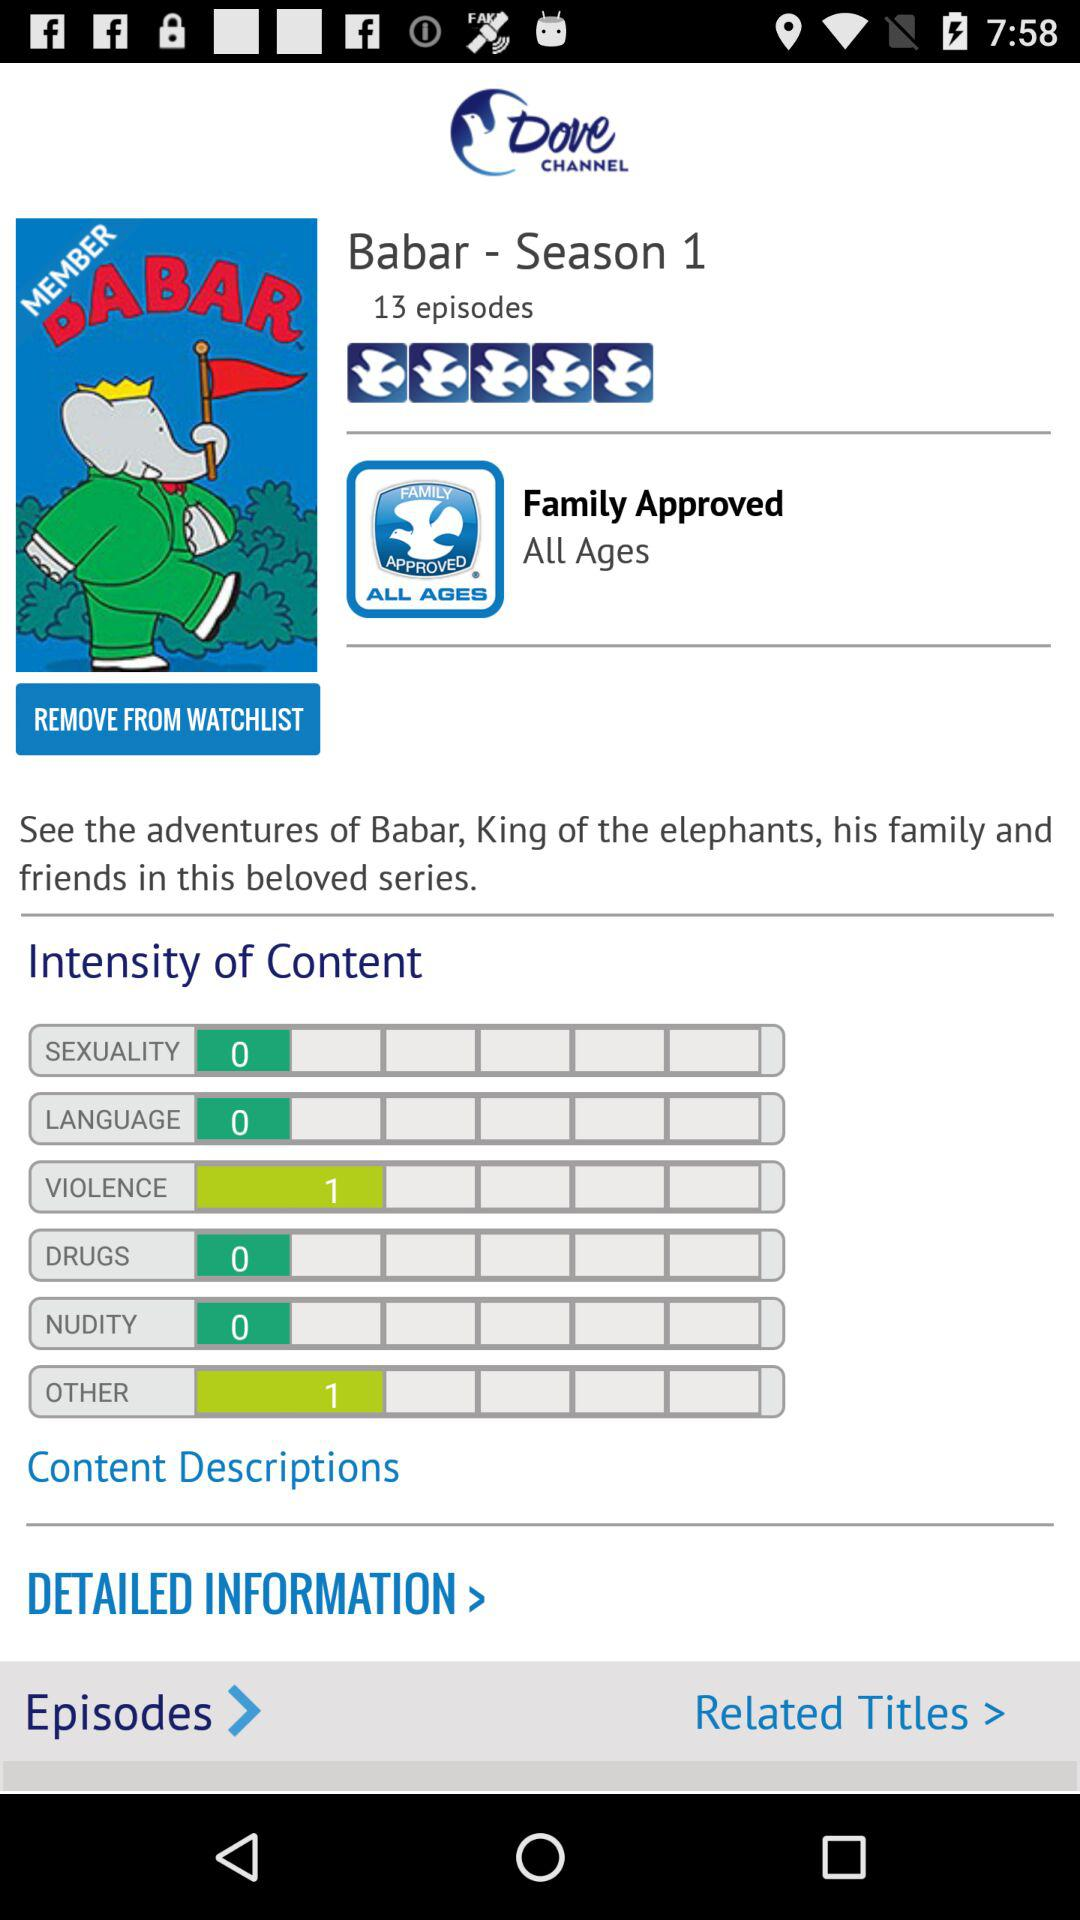What is age rating for the Barbar-Season 1?
When the provided information is insufficient, respond with <no answer>. <no answer> 